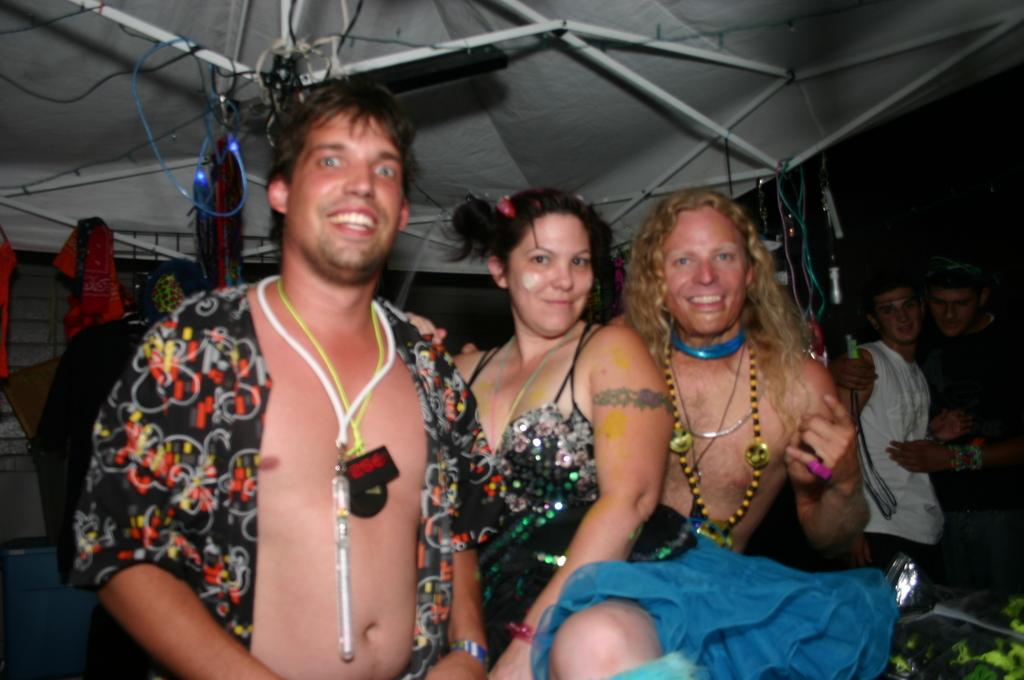Who or what is present in the image? There are people in the image. What is the facial expression of the people in the image? The people are smiling. What can be seen in the background of the image? There is a tent and other objects visible in the background of the image. What type of competition is taking place in the image? There is no competition present in the image; it simply shows people smiling with a tent in the background. 